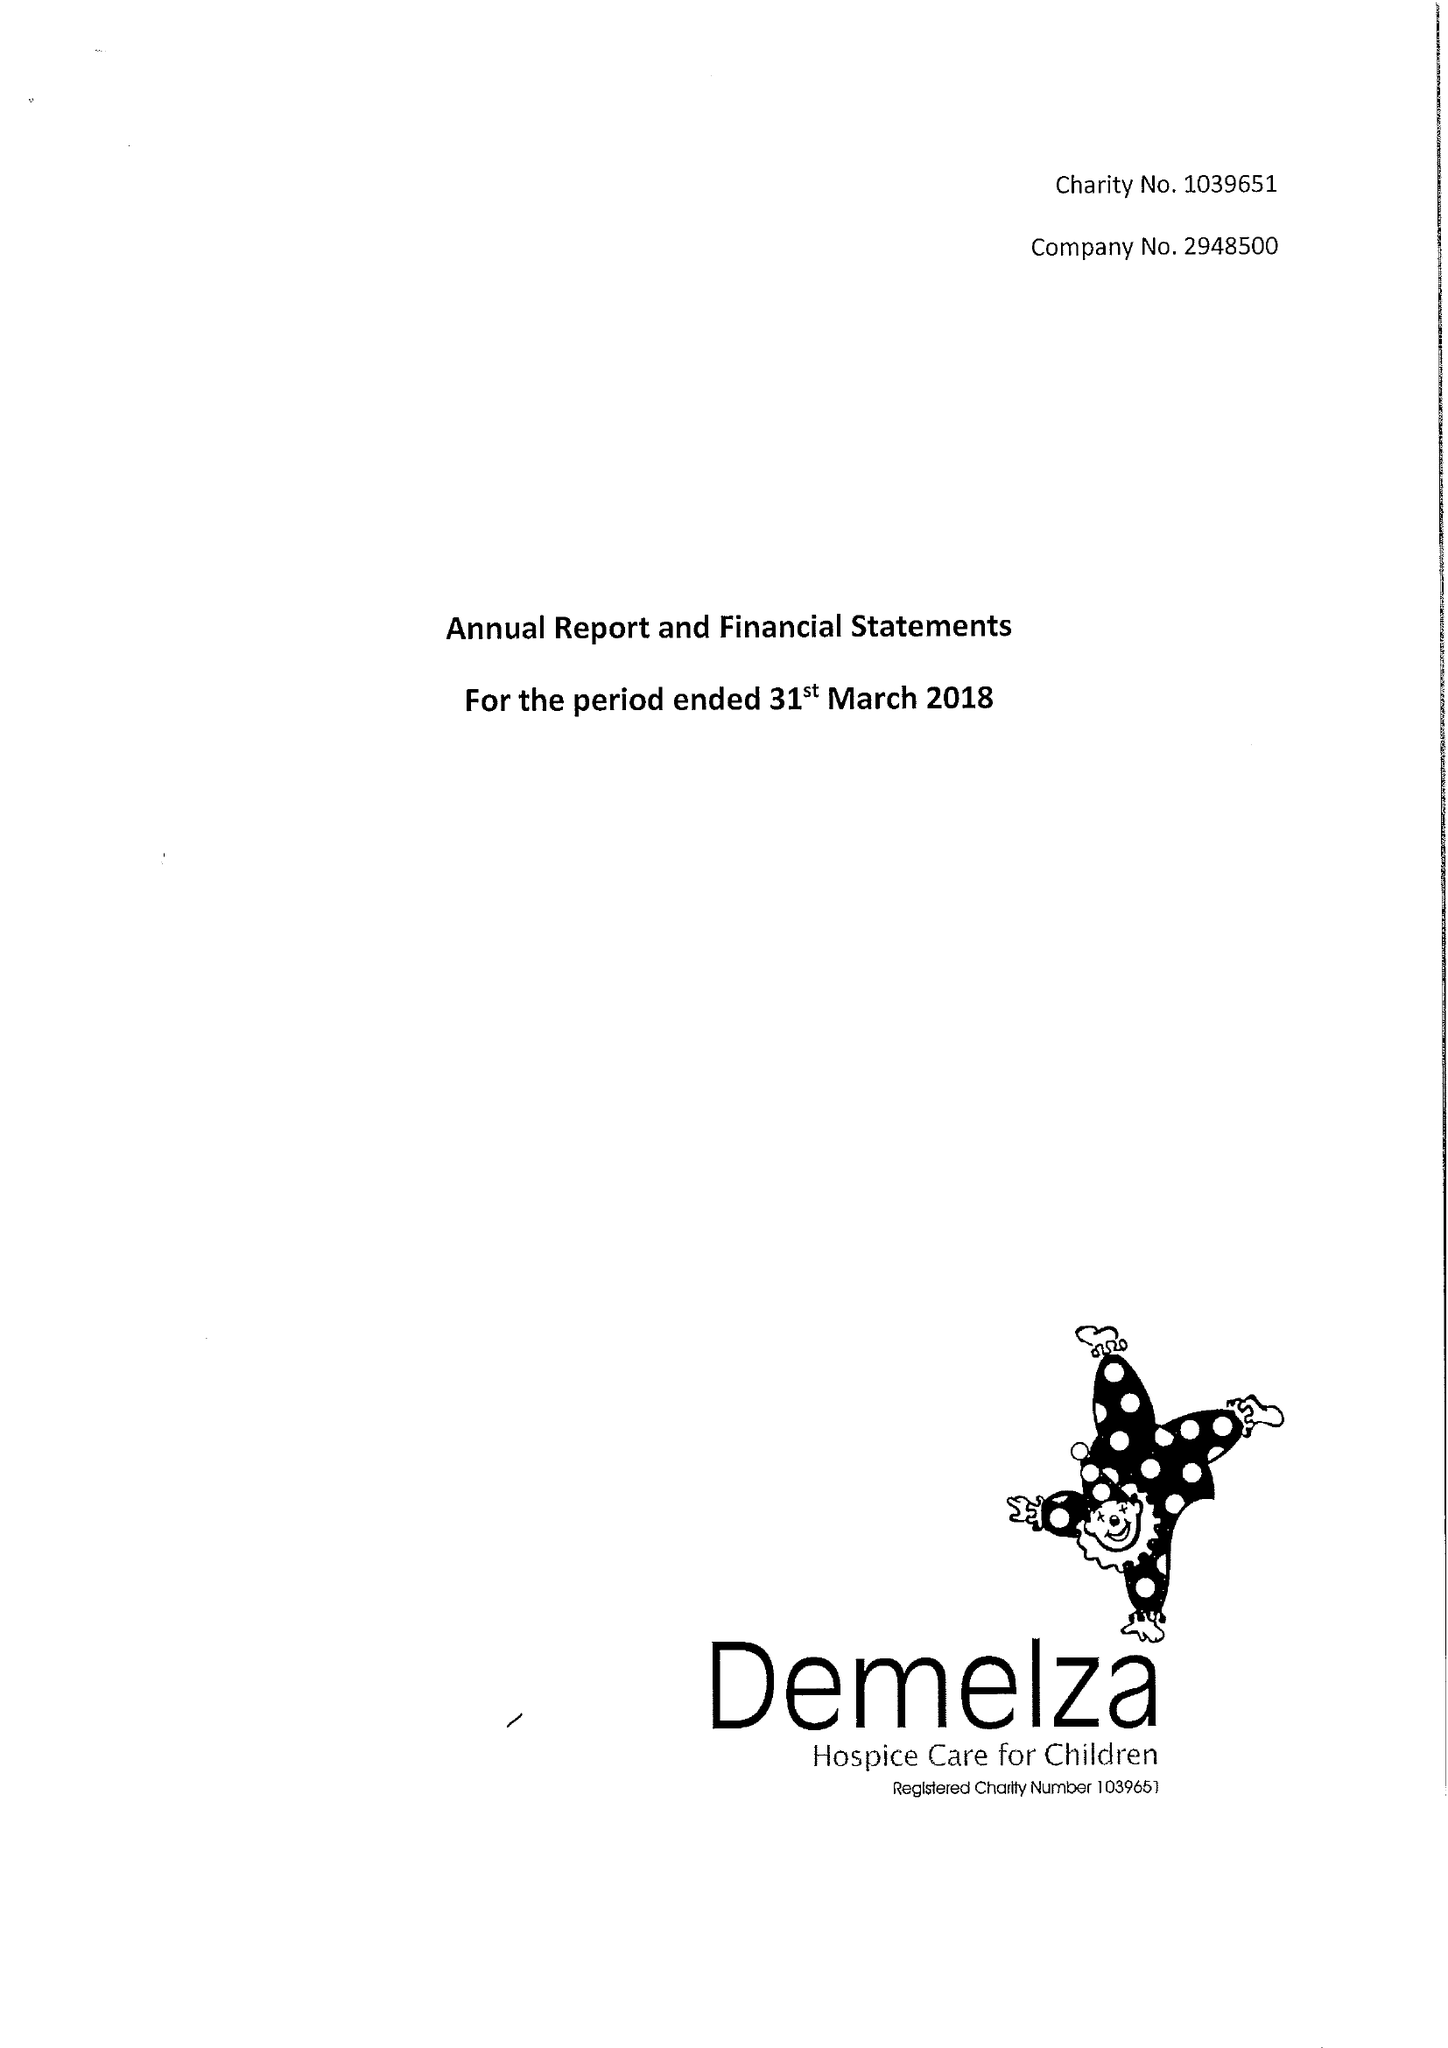What is the value for the charity_number?
Answer the question using a single word or phrase. 1039651 